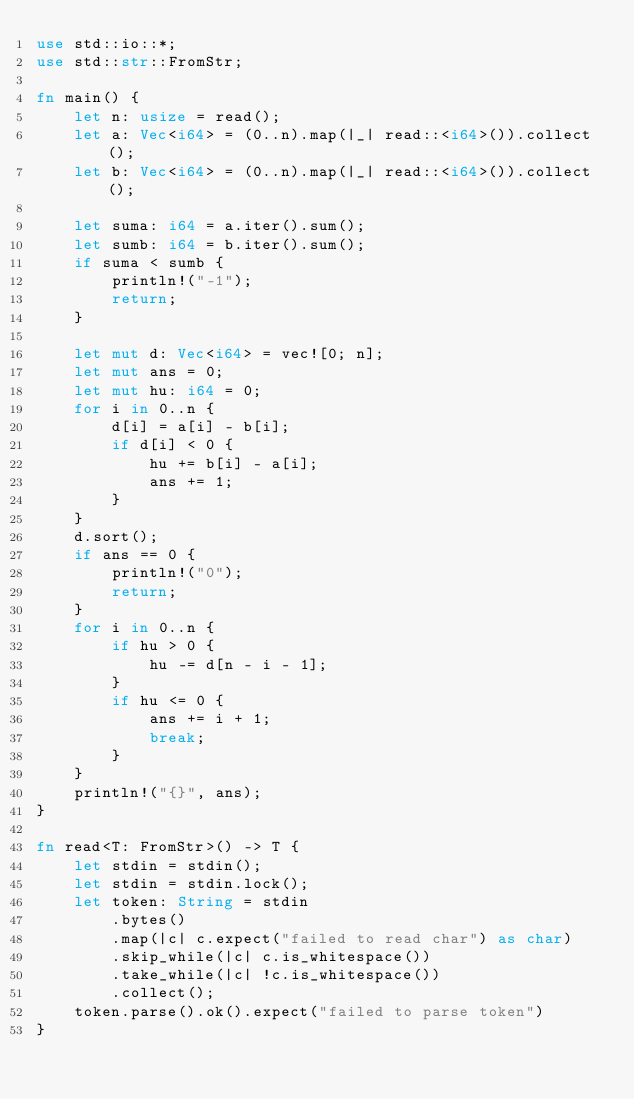Convert code to text. <code><loc_0><loc_0><loc_500><loc_500><_Rust_>use std::io::*;
use std::str::FromStr;

fn main() {
    let n: usize = read();
    let a: Vec<i64> = (0..n).map(|_| read::<i64>()).collect();
    let b: Vec<i64> = (0..n).map(|_| read::<i64>()).collect();

    let suma: i64 = a.iter().sum();
    let sumb: i64 = b.iter().sum();
    if suma < sumb {
        println!("-1");
        return;
    }

    let mut d: Vec<i64> = vec![0; n];
    let mut ans = 0;
    let mut hu: i64 = 0;
    for i in 0..n {
        d[i] = a[i] - b[i];
        if d[i] < 0 {
            hu += b[i] - a[i];
            ans += 1;
        }
    }
    d.sort();
    if ans == 0 {
        println!("0");
        return;
    }
    for i in 0..n {
        if hu > 0 {
            hu -= d[n - i - 1];
        }
        if hu <= 0 {
            ans += i + 1;
            break;
        }
    }
    println!("{}", ans);
}

fn read<T: FromStr>() -> T {
    let stdin = stdin();
    let stdin = stdin.lock();
    let token: String = stdin
        .bytes()
        .map(|c| c.expect("failed to read char") as char)
        .skip_while(|c| c.is_whitespace())
        .take_while(|c| !c.is_whitespace())
        .collect();
    token.parse().ok().expect("failed to parse token")
}
</code> 